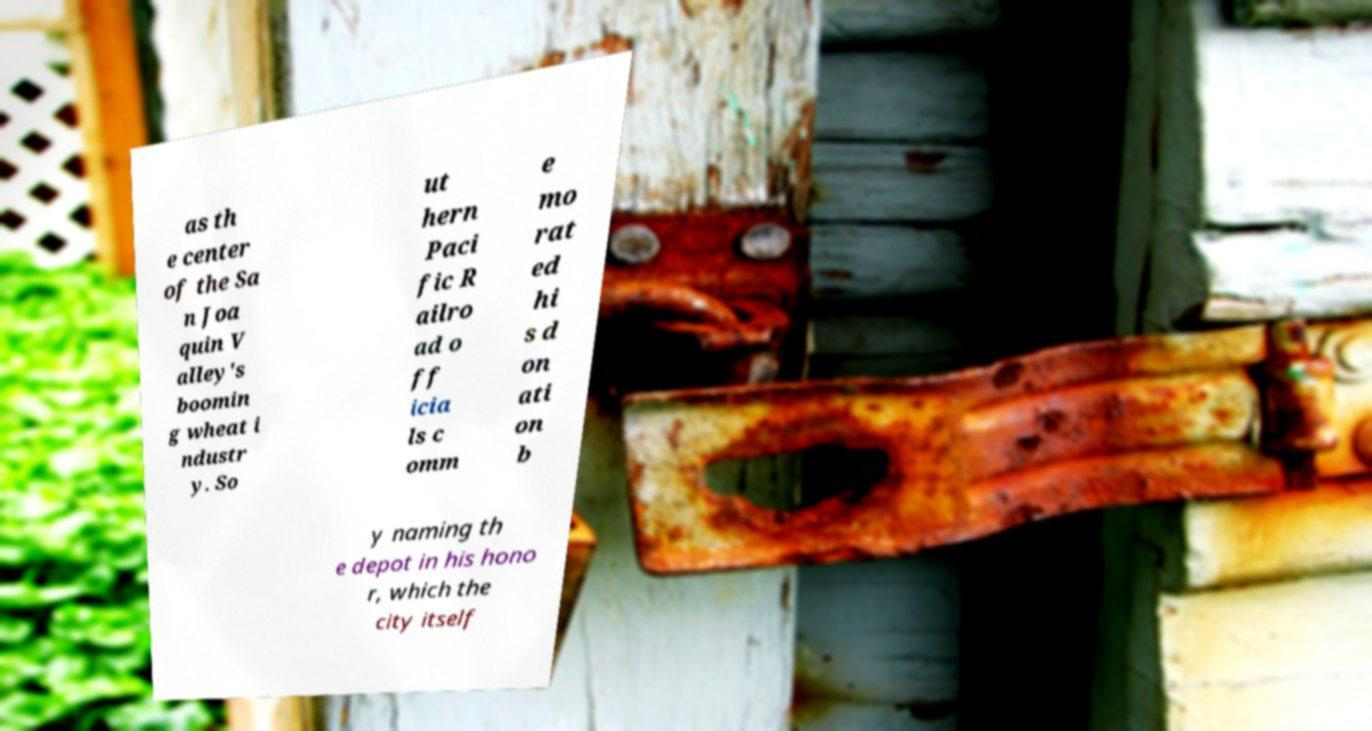For documentation purposes, I need the text within this image transcribed. Could you provide that? as th e center of the Sa n Joa quin V alley's boomin g wheat i ndustr y. So ut hern Paci fic R ailro ad o ff icia ls c omm e mo rat ed hi s d on ati on b y naming th e depot in his hono r, which the city itself 